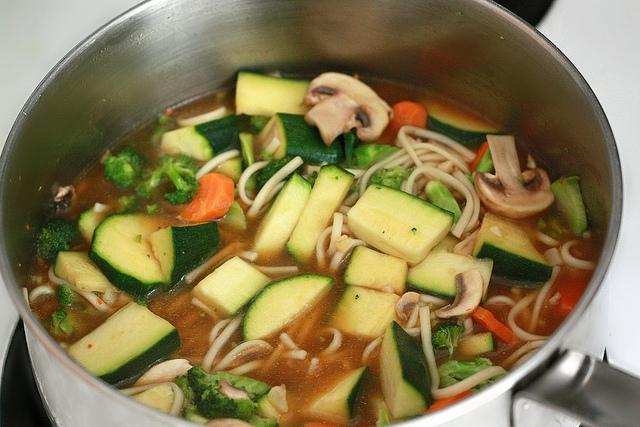How many broccolis are visible?
Give a very brief answer. 2. 